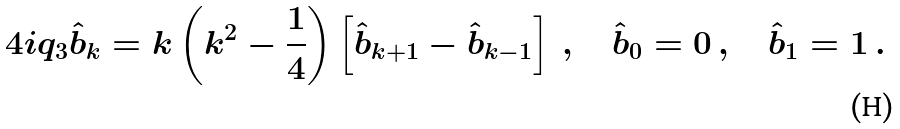Convert formula to latex. <formula><loc_0><loc_0><loc_500><loc_500>4 i q _ { 3 } \hat { b } _ { k } = k \left ( k ^ { 2 } - \frac { 1 } { 4 } \right ) \left [ \hat { b } _ { k + 1 } - \hat { b } _ { k - 1 } \right ] \, , \quad \hat { b } _ { 0 } = 0 \, , \quad \hat { b } _ { 1 } = 1 \, .</formula> 